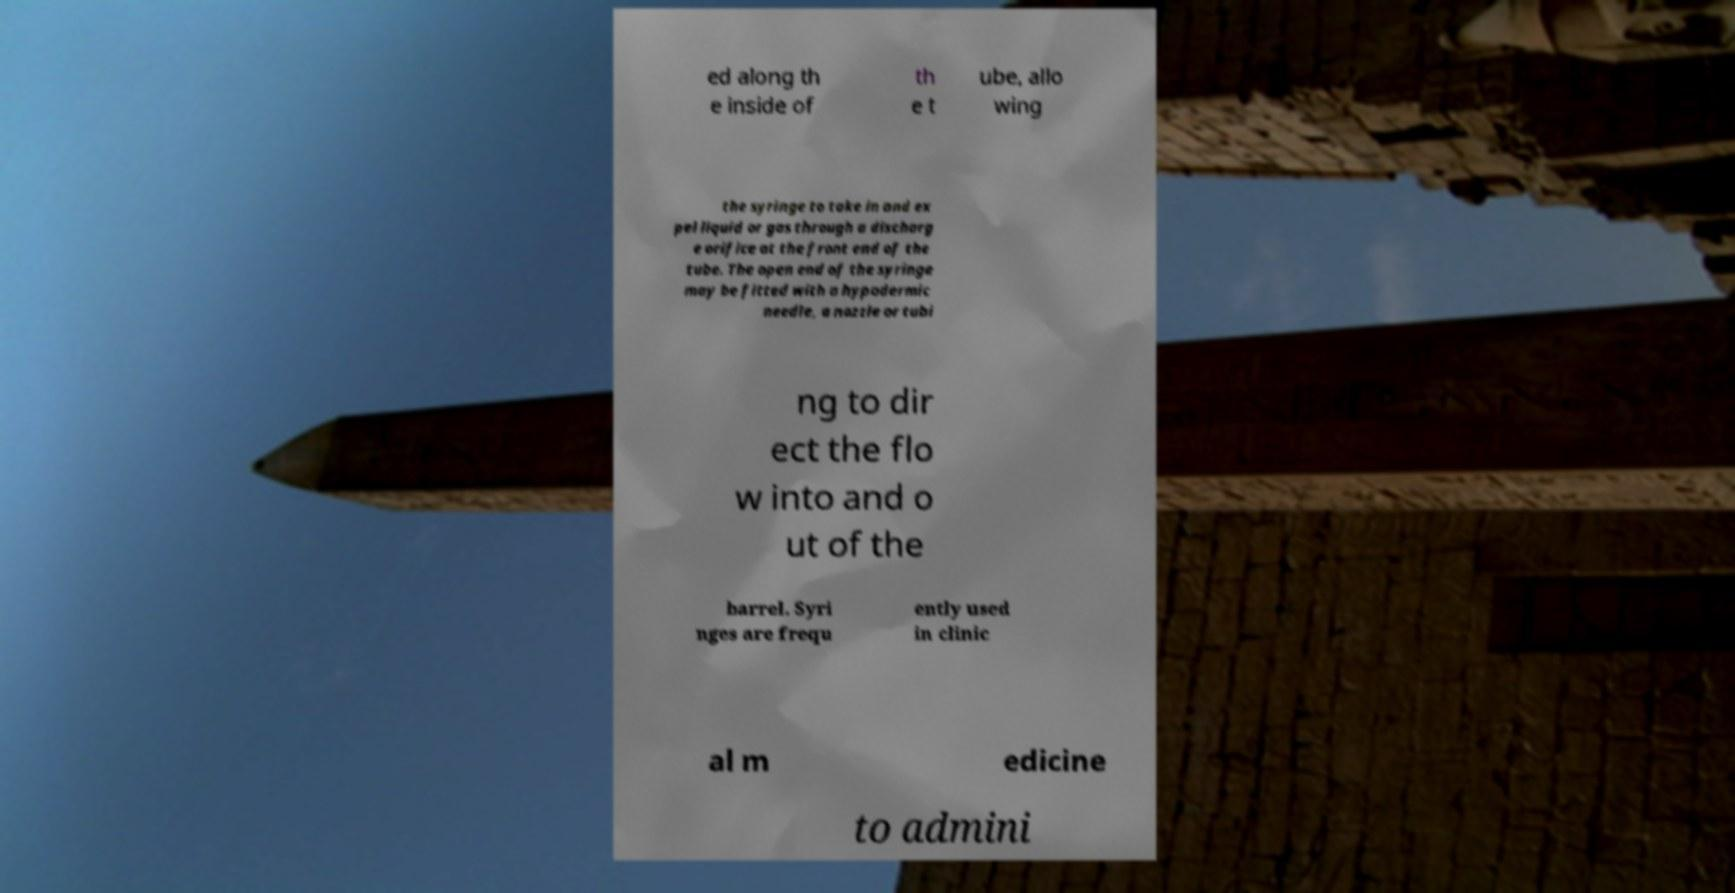Please identify and transcribe the text found in this image. ed along th e inside of th e t ube, allo wing the syringe to take in and ex pel liquid or gas through a discharg e orifice at the front end of the tube. The open end of the syringe may be fitted with a hypodermic needle, a nozzle or tubi ng to dir ect the flo w into and o ut of the barrel. Syri nges are frequ ently used in clinic al m edicine to admini 